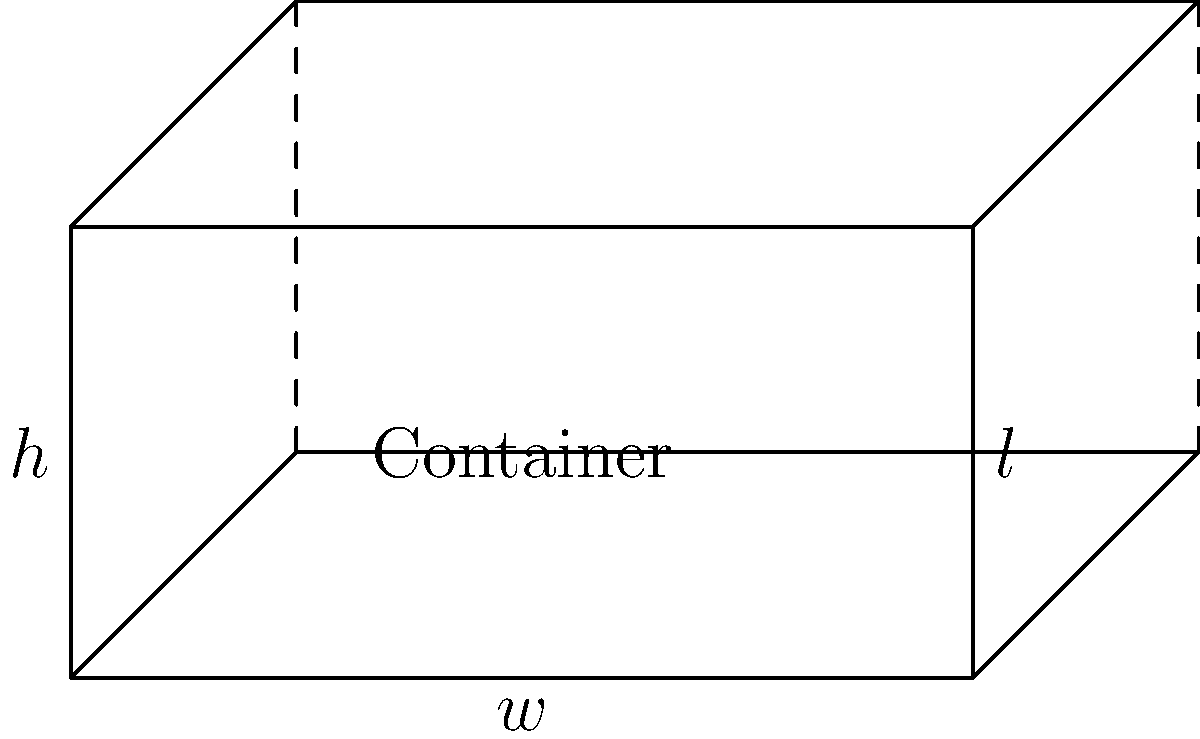As a content editor guiding a data analyst, you need to explain the optimization of a rectangular container's volume. The container is to be made from a 12 ft by 8 ft piece of cardboard by cutting equal squares from each corner and folding up the sides. What size should the corner squares be to maximize the volume of the container? Express your answer in terms of $x$, where $x$ represents the side length of the cut-out squares. To solve this optimization problem, we'll follow these steps:

1) Let $x$ be the side length of the square cut from each corner.

2) Express the dimensions of the container in terms of $x$:
   Length: $l = 12 - 2x$
   Width: $w = 8 - 2x$
   Height: $h = x$

3) The volume $V$ of the container is given by:
   $V = l \times w \times h = (12-2x)(8-2x)(x)$

4) Expand the equation:
   $V = (96-24x-16x+4x^2)x = 96x - 40x^2 + 4x^3$

5) To find the maximum volume, we need to find where the derivative of $V$ with respect to $x$ equals zero:
   $\frac{dV}{dx} = 96 - 80x + 12x^2$

6) Set this equal to zero and solve:
   $96 - 80x + 12x^2 = 0$
   $12x^2 - 80x + 96 = 0$

7) This is a quadratic equation. We can solve it using the quadratic formula:
   $x = \frac{-b \pm \sqrt{b^2 - 4ac}}{2a}$

   Where $a=12$, $b=-80$, and $c=96$

8) Solving this:
   $x = \frac{80 \pm \sqrt{6400 - 4608}}{24} = \frac{80 \pm \sqrt{1792}}{24} = \frac{80 \pm 42.33}{24}$

9) This gives us two solutions: $x \approx 5.10$ or $x \approx 1.57$

10) Since we're looking for the maximum volume, and the container dimensions must be positive, we choose the smaller value: $x \approx 1.57$

Therefore, to maximize the volume, the side length of the cut-out squares should be approximately 1.57 ft.
Answer: $x \approx 1.57$ ft 